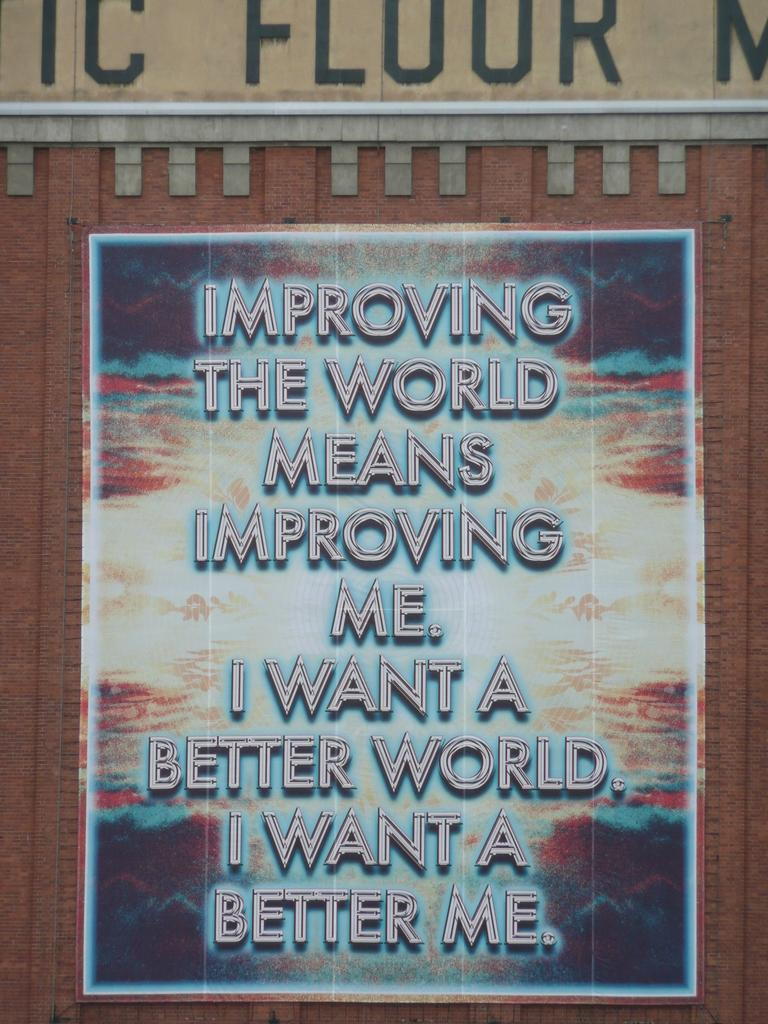<image>
Offer a succinct explanation of the picture presented. A poster with the background of a cloudy sky and words about a better world. 